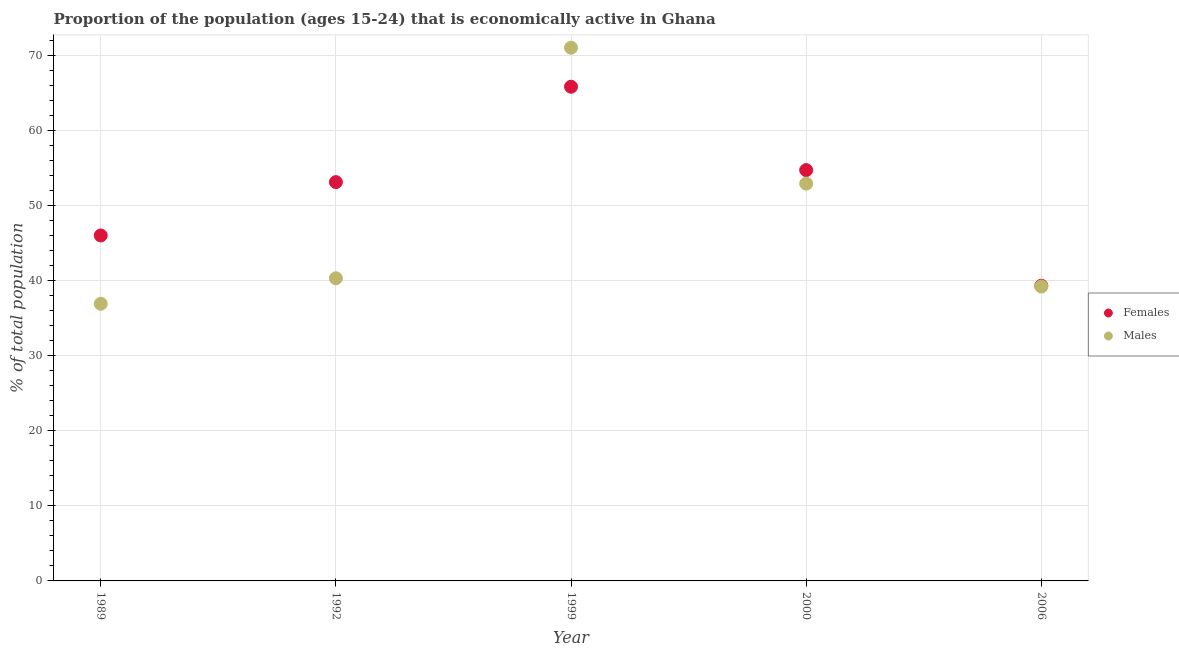Is the number of dotlines equal to the number of legend labels?
Your answer should be compact. Yes. What is the percentage of economically active male population in 1989?
Offer a very short reply. 36.9. Across all years, what is the maximum percentage of economically active female population?
Your response must be concise. 65.8. Across all years, what is the minimum percentage of economically active male population?
Provide a succinct answer. 36.9. In which year was the percentage of economically active female population maximum?
Offer a very short reply. 1999. In which year was the percentage of economically active female population minimum?
Your answer should be compact. 2006. What is the total percentage of economically active male population in the graph?
Keep it short and to the point. 240.3. What is the difference between the percentage of economically active female population in 1989 and that in 2000?
Your answer should be very brief. -8.7. What is the difference between the percentage of economically active male population in 1989 and the percentage of economically active female population in 1992?
Provide a short and direct response. -16.2. What is the average percentage of economically active male population per year?
Ensure brevity in your answer.  48.06. In the year 1992, what is the difference between the percentage of economically active female population and percentage of economically active male population?
Keep it short and to the point. 12.8. In how many years, is the percentage of economically active female population greater than 26 %?
Give a very brief answer. 5. What is the ratio of the percentage of economically active female population in 1989 to that in 2000?
Your answer should be very brief. 0.84. Is the percentage of economically active male population in 1992 less than that in 2006?
Keep it short and to the point. No. What is the difference between the highest and the second highest percentage of economically active male population?
Your answer should be compact. 18.1. What is the difference between the highest and the lowest percentage of economically active male population?
Offer a very short reply. 34.1. Is the percentage of economically active male population strictly greater than the percentage of economically active female population over the years?
Ensure brevity in your answer.  No. How many years are there in the graph?
Provide a succinct answer. 5. What is the difference between two consecutive major ticks on the Y-axis?
Provide a succinct answer. 10. Are the values on the major ticks of Y-axis written in scientific E-notation?
Give a very brief answer. No. Does the graph contain any zero values?
Offer a very short reply. No. Where does the legend appear in the graph?
Provide a short and direct response. Center right. How many legend labels are there?
Give a very brief answer. 2. What is the title of the graph?
Provide a succinct answer. Proportion of the population (ages 15-24) that is economically active in Ghana. Does "Underweight" appear as one of the legend labels in the graph?
Your response must be concise. No. What is the label or title of the X-axis?
Offer a terse response. Year. What is the label or title of the Y-axis?
Provide a short and direct response. % of total population. What is the % of total population in Females in 1989?
Give a very brief answer. 46. What is the % of total population of Males in 1989?
Ensure brevity in your answer.  36.9. What is the % of total population in Females in 1992?
Keep it short and to the point. 53.1. What is the % of total population of Males in 1992?
Your answer should be very brief. 40.3. What is the % of total population of Females in 1999?
Provide a succinct answer. 65.8. What is the % of total population in Males in 1999?
Your response must be concise. 71. What is the % of total population of Females in 2000?
Your answer should be very brief. 54.7. What is the % of total population of Males in 2000?
Your answer should be compact. 52.9. What is the % of total population in Females in 2006?
Offer a terse response. 39.3. What is the % of total population of Males in 2006?
Your answer should be compact. 39.2. Across all years, what is the maximum % of total population in Females?
Your response must be concise. 65.8. Across all years, what is the minimum % of total population in Females?
Offer a very short reply. 39.3. Across all years, what is the minimum % of total population of Males?
Your answer should be compact. 36.9. What is the total % of total population in Females in the graph?
Offer a very short reply. 258.9. What is the total % of total population of Males in the graph?
Keep it short and to the point. 240.3. What is the difference between the % of total population in Males in 1989 and that in 1992?
Offer a very short reply. -3.4. What is the difference between the % of total population in Females in 1989 and that in 1999?
Offer a terse response. -19.8. What is the difference between the % of total population in Males in 1989 and that in 1999?
Provide a short and direct response. -34.1. What is the difference between the % of total population of Females in 1989 and that in 2000?
Ensure brevity in your answer.  -8.7. What is the difference between the % of total population of Females in 1989 and that in 2006?
Give a very brief answer. 6.7. What is the difference between the % of total population of Males in 1989 and that in 2006?
Offer a terse response. -2.3. What is the difference between the % of total population in Males in 1992 and that in 1999?
Make the answer very short. -30.7. What is the difference between the % of total population in Females in 1992 and that in 2000?
Your answer should be very brief. -1.6. What is the difference between the % of total population in Females in 1992 and that in 2006?
Ensure brevity in your answer.  13.8. What is the difference between the % of total population of Males in 1992 and that in 2006?
Offer a very short reply. 1.1. What is the difference between the % of total population of Females in 1999 and that in 2000?
Offer a terse response. 11.1. What is the difference between the % of total population of Males in 1999 and that in 2000?
Keep it short and to the point. 18.1. What is the difference between the % of total population in Females in 1999 and that in 2006?
Offer a terse response. 26.5. What is the difference between the % of total population in Males in 1999 and that in 2006?
Ensure brevity in your answer.  31.8. What is the difference between the % of total population of Females in 1989 and the % of total population of Males in 1992?
Your response must be concise. 5.7. What is the difference between the % of total population of Females in 1989 and the % of total population of Males in 1999?
Offer a very short reply. -25. What is the difference between the % of total population of Females in 1989 and the % of total population of Males in 2000?
Offer a terse response. -6.9. What is the difference between the % of total population in Females in 1992 and the % of total population in Males in 1999?
Keep it short and to the point. -17.9. What is the difference between the % of total population in Females in 1992 and the % of total population in Males in 2006?
Offer a very short reply. 13.9. What is the difference between the % of total population in Females in 1999 and the % of total population in Males in 2000?
Provide a succinct answer. 12.9. What is the difference between the % of total population in Females in 1999 and the % of total population in Males in 2006?
Provide a short and direct response. 26.6. What is the average % of total population of Females per year?
Your answer should be very brief. 51.78. What is the average % of total population in Males per year?
Provide a short and direct response. 48.06. In the year 1992, what is the difference between the % of total population in Females and % of total population in Males?
Provide a short and direct response. 12.8. In the year 2000, what is the difference between the % of total population in Females and % of total population in Males?
Your answer should be compact. 1.8. What is the ratio of the % of total population in Females in 1989 to that in 1992?
Keep it short and to the point. 0.87. What is the ratio of the % of total population in Males in 1989 to that in 1992?
Keep it short and to the point. 0.92. What is the ratio of the % of total population in Females in 1989 to that in 1999?
Offer a terse response. 0.7. What is the ratio of the % of total population of Males in 1989 to that in 1999?
Offer a very short reply. 0.52. What is the ratio of the % of total population in Females in 1989 to that in 2000?
Your response must be concise. 0.84. What is the ratio of the % of total population of Males in 1989 to that in 2000?
Make the answer very short. 0.7. What is the ratio of the % of total population of Females in 1989 to that in 2006?
Your answer should be compact. 1.17. What is the ratio of the % of total population in Males in 1989 to that in 2006?
Provide a short and direct response. 0.94. What is the ratio of the % of total population in Females in 1992 to that in 1999?
Offer a very short reply. 0.81. What is the ratio of the % of total population in Males in 1992 to that in 1999?
Your answer should be very brief. 0.57. What is the ratio of the % of total population in Females in 1992 to that in 2000?
Your answer should be very brief. 0.97. What is the ratio of the % of total population in Males in 1992 to that in 2000?
Give a very brief answer. 0.76. What is the ratio of the % of total population in Females in 1992 to that in 2006?
Keep it short and to the point. 1.35. What is the ratio of the % of total population in Males in 1992 to that in 2006?
Ensure brevity in your answer.  1.03. What is the ratio of the % of total population of Females in 1999 to that in 2000?
Your response must be concise. 1.2. What is the ratio of the % of total population of Males in 1999 to that in 2000?
Your answer should be compact. 1.34. What is the ratio of the % of total population of Females in 1999 to that in 2006?
Give a very brief answer. 1.67. What is the ratio of the % of total population of Males in 1999 to that in 2006?
Keep it short and to the point. 1.81. What is the ratio of the % of total population of Females in 2000 to that in 2006?
Offer a very short reply. 1.39. What is the ratio of the % of total population in Males in 2000 to that in 2006?
Your answer should be very brief. 1.35. What is the difference between the highest and the lowest % of total population in Males?
Make the answer very short. 34.1. 